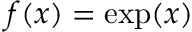Convert formula to latex. <formula><loc_0><loc_0><loc_500><loc_500>f ( x ) = \exp ( x )</formula> 